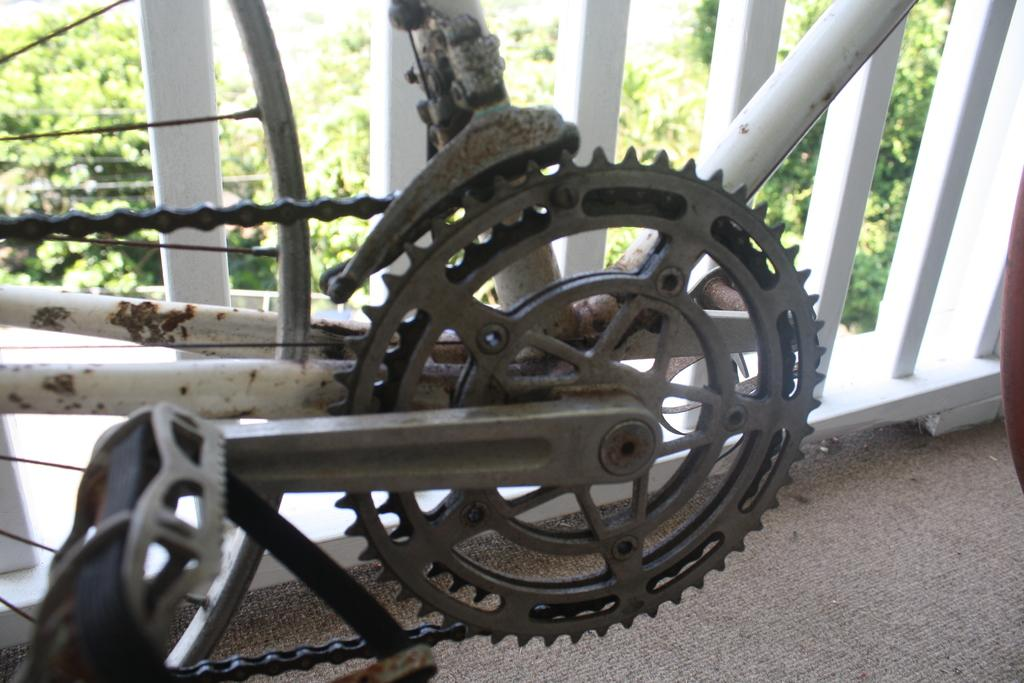What is the main object in the image? There is a cycle chain in the image. What can be seen in the background of the image? There is railing and trees with green color visible in the background of the image. What statement is written on the box in the image? There is no box present in the image, so no statement can be read from it. 